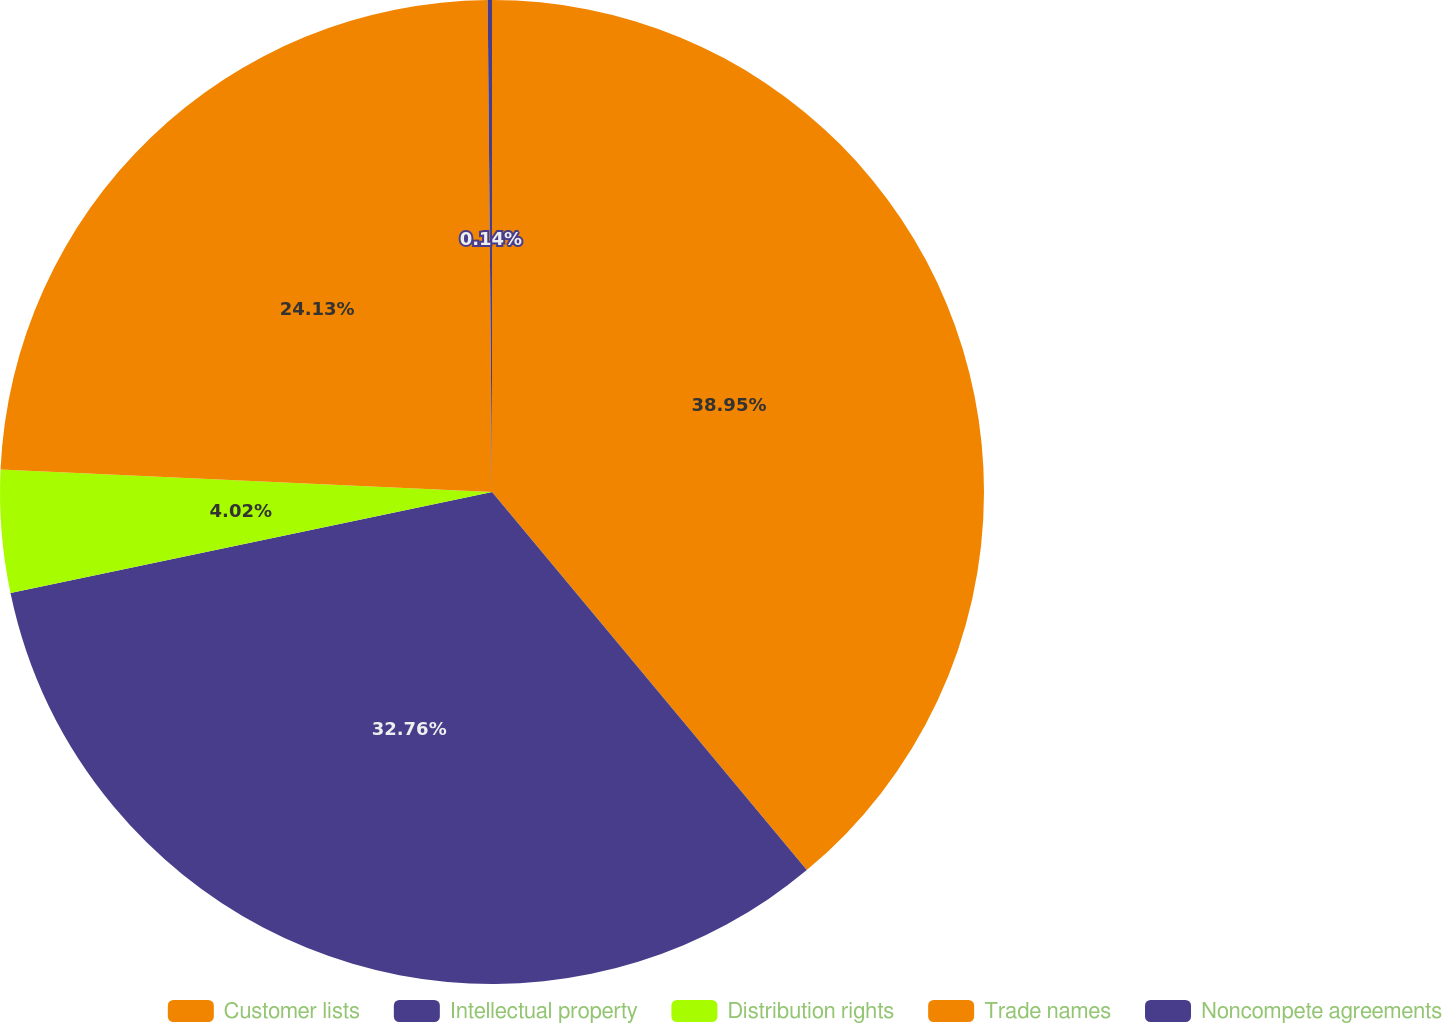<chart> <loc_0><loc_0><loc_500><loc_500><pie_chart><fcel>Customer lists<fcel>Intellectual property<fcel>Distribution rights<fcel>Trade names<fcel>Noncompete agreements<nl><fcel>38.95%<fcel>32.76%<fcel>4.02%<fcel>24.13%<fcel>0.14%<nl></chart> 